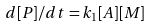Convert formula to latex. <formula><loc_0><loc_0><loc_500><loc_500>d [ P ] / d t = k _ { 1 } [ A ] [ M ]</formula> 